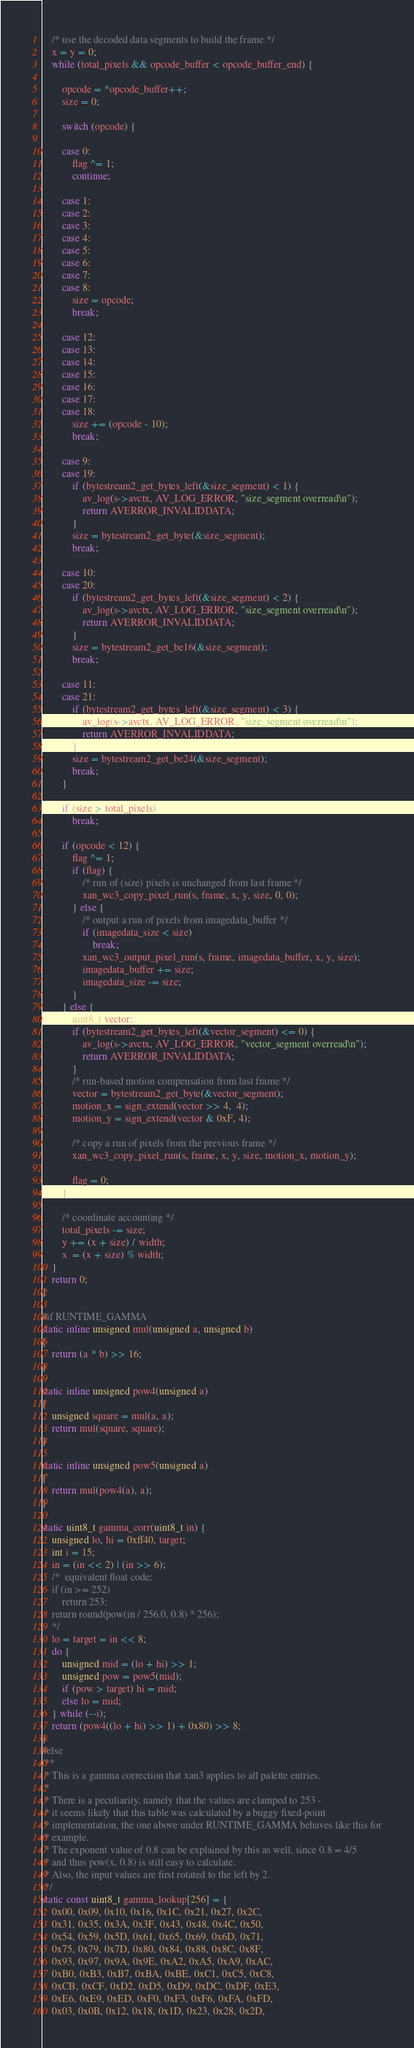<code> <loc_0><loc_0><loc_500><loc_500><_C_>
    /* use the decoded data segments to build the frame */
    x = y = 0;
    while (total_pixels && opcode_buffer < opcode_buffer_end) {

        opcode = *opcode_buffer++;
        size = 0;

        switch (opcode) {

        case 0:
            flag ^= 1;
            continue;

        case 1:
        case 2:
        case 3:
        case 4:
        case 5:
        case 6:
        case 7:
        case 8:
            size = opcode;
            break;

        case 12:
        case 13:
        case 14:
        case 15:
        case 16:
        case 17:
        case 18:
            size += (opcode - 10);
            break;

        case 9:
        case 19:
            if (bytestream2_get_bytes_left(&size_segment) < 1) {
                av_log(s->avctx, AV_LOG_ERROR, "size_segment overread\n");
                return AVERROR_INVALIDDATA;
            }
            size = bytestream2_get_byte(&size_segment);
            break;

        case 10:
        case 20:
            if (bytestream2_get_bytes_left(&size_segment) < 2) {
                av_log(s->avctx, AV_LOG_ERROR, "size_segment overread\n");
                return AVERROR_INVALIDDATA;
            }
            size = bytestream2_get_be16(&size_segment);
            break;

        case 11:
        case 21:
            if (bytestream2_get_bytes_left(&size_segment) < 3) {
                av_log(s->avctx, AV_LOG_ERROR, "size_segment overread\n");
                return AVERROR_INVALIDDATA;
            }
            size = bytestream2_get_be24(&size_segment);
            break;
        }

        if (size > total_pixels)
            break;

        if (opcode < 12) {
            flag ^= 1;
            if (flag) {
                /* run of (size) pixels is unchanged from last frame */
                xan_wc3_copy_pixel_run(s, frame, x, y, size, 0, 0);
            } else {
                /* output a run of pixels from imagedata_buffer */
                if (imagedata_size < size)
                    break;
                xan_wc3_output_pixel_run(s, frame, imagedata_buffer, x, y, size);
                imagedata_buffer += size;
                imagedata_size -= size;
            }
        } else {
            uint8_t vector;
            if (bytestream2_get_bytes_left(&vector_segment) <= 0) {
                av_log(s->avctx, AV_LOG_ERROR, "vector_segment overread\n");
                return AVERROR_INVALIDDATA;
            }
            /* run-based motion compensation from last frame */
            vector = bytestream2_get_byte(&vector_segment);
            motion_x = sign_extend(vector >> 4,  4);
            motion_y = sign_extend(vector & 0xF, 4);

            /* copy a run of pixels from the previous frame */
            xan_wc3_copy_pixel_run(s, frame, x, y, size, motion_x, motion_y);

            flag = 0;
        }

        /* coordinate accounting */
        total_pixels -= size;
        y += (x + size) / width;
        x  = (x + size) % width;
    }
    return 0;
}

#if RUNTIME_GAMMA
static inline unsigned mul(unsigned a, unsigned b)
{
    return (a * b) >> 16;
}

static inline unsigned pow4(unsigned a)
{
    unsigned square = mul(a, a);
    return mul(square, square);
}

static inline unsigned pow5(unsigned a)
{
    return mul(pow4(a), a);
}

static uint8_t gamma_corr(uint8_t in) {
    unsigned lo, hi = 0xff40, target;
    int i = 15;
    in = (in << 2) | (in >> 6);
    /*  equivalent float code:
    if (in >= 252)
        return 253;
    return round(pow(in / 256.0, 0.8) * 256);
    */
    lo = target = in << 8;
    do {
        unsigned mid = (lo + hi) >> 1;
        unsigned pow = pow5(mid);
        if (pow > target) hi = mid;
        else lo = mid;
    } while (--i);
    return (pow4((lo + hi) >> 1) + 0x80) >> 8;
}
#else
/**
 * This is a gamma correction that xan3 applies to all palette entries.
 *
 * There is a peculiarity, namely that the values are clamped to 253 -
 * it seems likely that this table was calculated by a buggy fixed-point
 * implementation, the one above under RUNTIME_GAMMA behaves like this for
 * example.
 * The exponent value of 0.8 can be explained by this as well, since 0.8 = 4/5
 * and thus pow(x, 0.8) is still easy to calculate.
 * Also, the input values are first rotated to the left by 2.
 */
static const uint8_t gamma_lookup[256] = {
    0x00, 0x09, 0x10, 0x16, 0x1C, 0x21, 0x27, 0x2C,
    0x31, 0x35, 0x3A, 0x3F, 0x43, 0x48, 0x4C, 0x50,
    0x54, 0x59, 0x5D, 0x61, 0x65, 0x69, 0x6D, 0x71,
    0x75, 0x79, 0x7D, 0x80, 0x84, 0x88, 0x8C, 0x8F,
    0x93, 0x97, 0x9A, 0x9E, 0xA2, 0xA5, 0xA9, 0xAC,
    0xB0, 0xB3, 0xB7, 0xBA, 0xBE, 0xC1, 0xC5, 0xC8,
    0xCB, 0xCF, 0xD2, 0xD5, 0xD9, 0xDC, 0xDF, 0xE3,
    0xE6, 0xE9, 0xED, 0xF0, 0xF3, 0xF6, 0xFA, 0xFD,
    0x03, 0x0B, 0x12, 0x18, 0x1D, 0x23, 0x28, 0x2D,</code> 